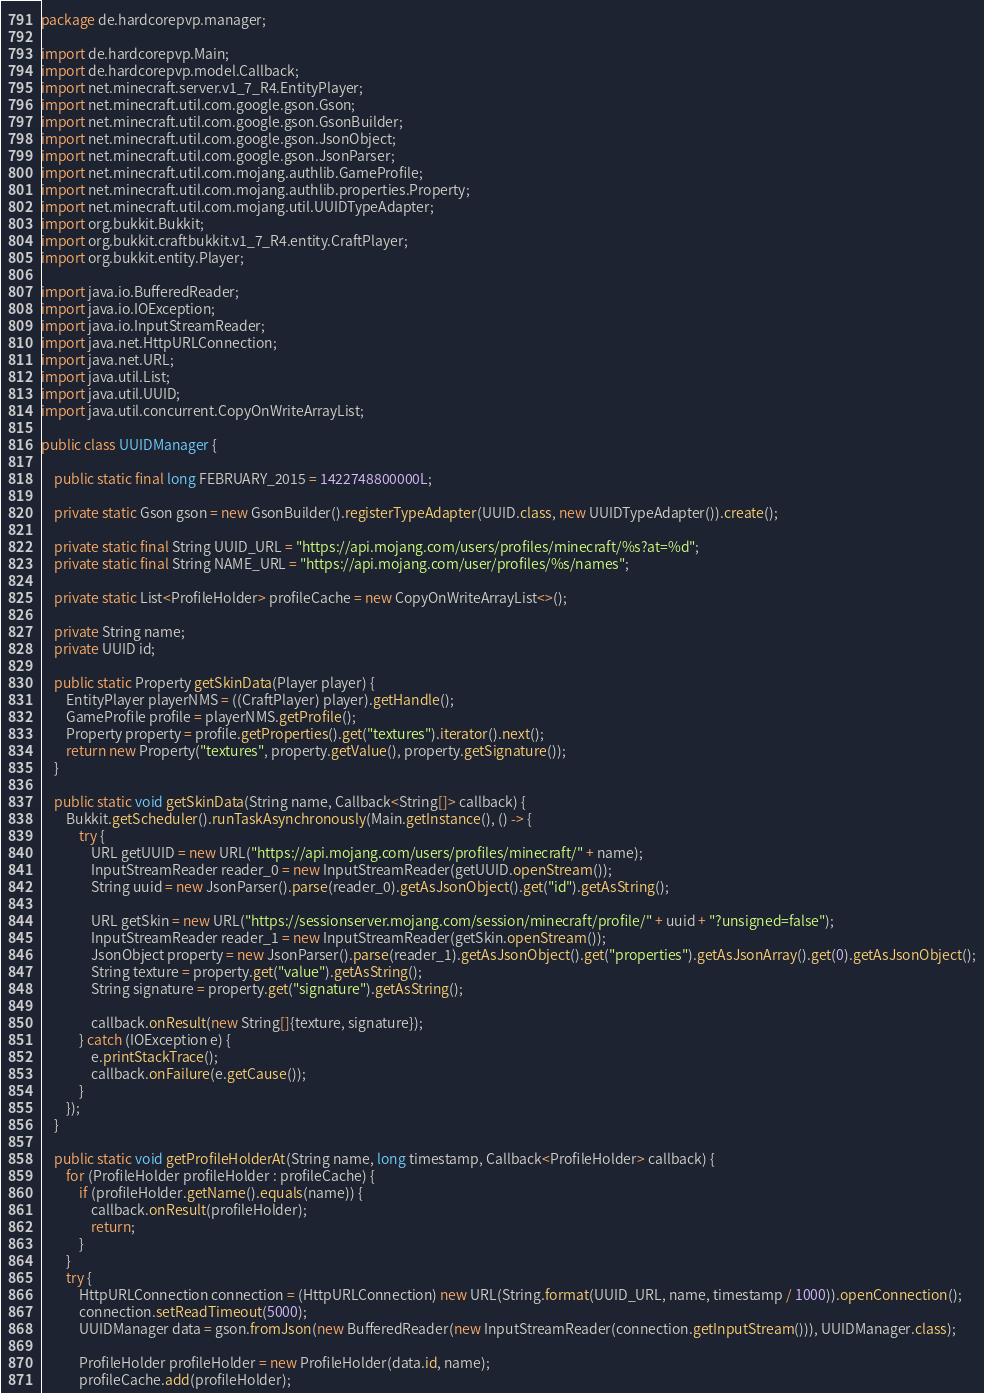Convert code to text. <code><loc_0><loc_0><loc_500><loc_500><_Java_>package de.hardcorepvp.manager;

import de.hardcorepvp.Main;
import de.hardcorepvp.model.Callback;
import net.minecraft.server.v1_7_R4.EntityPlayer;
import net.minecraft.util.com.google.gson.Gson;
import net.minecraft.util.com.google.gson.GsonBuilder;
import net.minecraft.util.com.google.gson.JsonObject;
import net.minecraft.util.com.google.gson.JsonParser;
import net.minecraft.util.com.mojang.authlib.GameProfile;
import net.minecraft.util.com.mojang.authlib.properties.Property;
import net.minecraft.util.com.mojang.util.UUIDTypeAdapter;
import org.bukkit.Bukkit;
import org.bukkit.craftbukkit.v1_7_R4.entity.CraftPlayer;
import org.bukkit.entity.Player;

import java.io.BufferedReader;
import java.io.IOException;
import java.io.InputStreamReader;
import java.net.HttpURLConnection;
import java.net.URL;
import java.util.List;
import java.util.UUID;
import java.util.concurrent.CopyOnWriteArrayList;

public class UUIDManager {

	public static final long FEBRUARY_2015 = 1422748800000L;

	private static Gson gson = new GsonBuilder().registerTypeAdapter(UUID.class, new UUIDTypeAdapter()).create();

	private static final String UUID_URL = "https://api.mojang.com/users/profiles/minecraft/%s?at=%d";
	private static final String NAME_URL = "https://api.mojang.com/user/profiles/%s/names";

	private static List<ProfileHolder> profileCache = new CopyOnWriteArrayList<>();

	private String name;
	private UUID id;

	public static Property getSkinData(Player player) {
		EntityPlayer playerNMS = ((CraftPlayer) player).getHandle();
		GameProfile profile = playerNMS.getProfile();
		Property property = profile.getProperties().get("textures").iterator().next();
		return new Property("textures", property.getValue(), property.getSignature());
	}

	public static void getSkinData(String name, Callback<String[]> callback) {
		Bukkit.getScheduler().runTaskAsynchronously(Main.getInstance(), () -> {
			try {
				URL getUUID = new URL("https://api.mojang.com/users/profiles/minecraft/" + name);
				InputStreamReader reader_0 = new InputStreamReader(getUUID.openStream());
				String uuid = new JsonParser().parse(reader_0).getAsJsonObject().get("id").getAsString();

				URL getSkin = new URL("https://sessionserver.mojang.com/session/minecraft/profile/" + uuid + "?unsigned=false");
				InputStreamReader reader_1 = new InputStreamReader(getSkin.openStream());
				JsonObject property = new JsonParser().parse(reader_1).getAsJsonObject().get("properties").getAsJsonArray().get(0).getAsJsonObject();
				String texture = property.get("value").getAsString();
				String signature = property.get("signature").getAsString();

				callback.onResult(new String[]{texture, signature});
			} catch (IOException e) {
				e.printStackTrace();
				callback.onFailure(e.getCause());
			}
		});
	}

	public static void getProfileHolderAt(String name, long timestamp, Callback<ProfileHolder> callback) {
		for (ProfileHolder profileHolder : profileCache) {
			if (profileHolder.getName().equals(name)) {
				callback.onResult(profileHolder);
				return;
			}
		}
		try {
			HttpURLConnection connection = (HttpURLConnection) new URL(String.format(UUID_URL, name, timestamp / 1000)).openConnection();
			connection.setReadTimeout(5000);
			UUIDManager data = gson.fromJson(new BufferedReader(new InputStreamReader(connection.getInputStream())), UUIDManager.class);

			ProfileHolder profileHolder = new ProfileHolder(data.id, name);
			profileCache.add(profileHolder);
</code> 